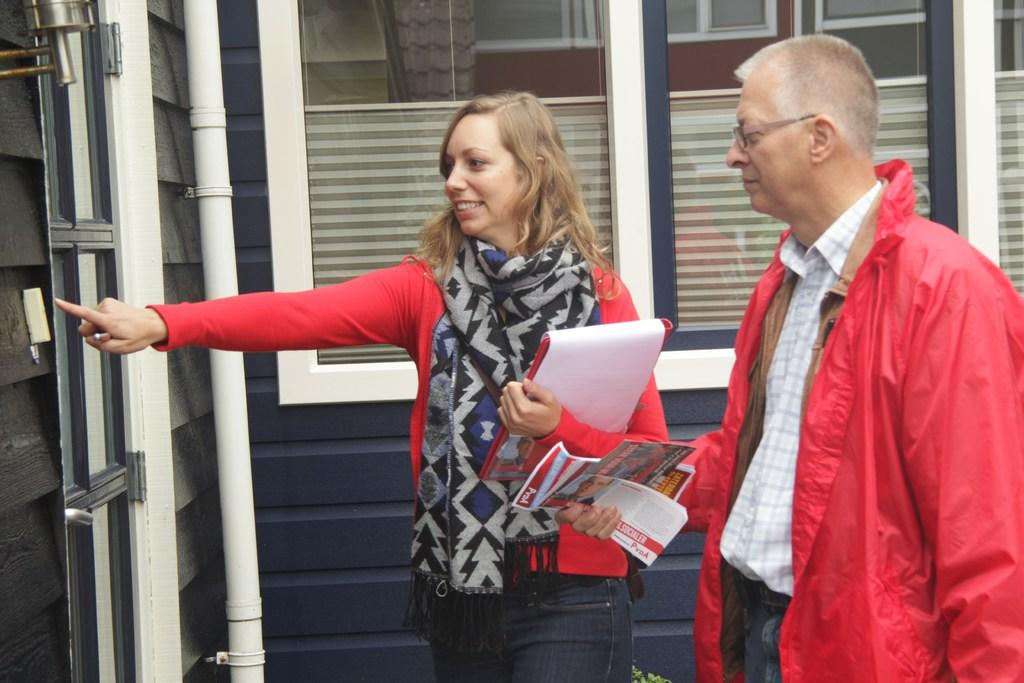How many people are present in the image? There are two persons in the image. What are the persons holding in the image? The persons are holding papers. What architectural feature can be seen in the image? There is a window visible in the image. What object can be seen in the image that is not related to the persons or the window? There is a pipe in the image. Can you describe another possible feature on the left side of the image? There may be another window on the left side of the image. What type of plate is being used by the hen in the image? There is no hen or plate present in the image. How many boats can be seen in the image? There are no boats visible in the image. 